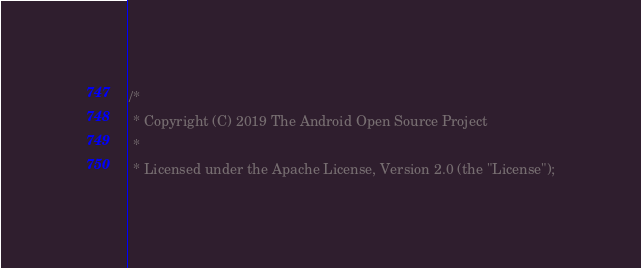Convert code to text. <code><loc_0><loc_0><loc_500><loc_500><_ObjectiveC_>/*
 * Copyright (C) 2019 The Android Open Source Project
 *
 * Licensed under the Apache License, Version 2.0 (the "License");</code> 